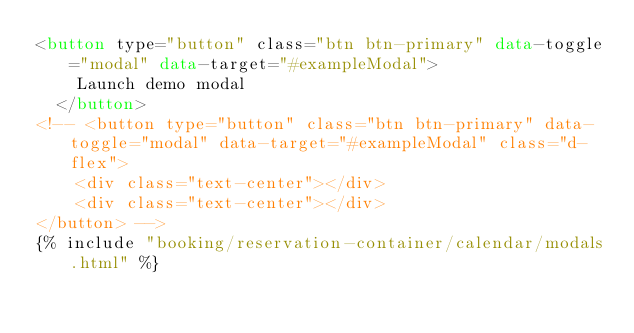<code> <loc_0><loc_0><loc_500><loc_500><_HTML_><button type="button" class="btn btn-primary" data-toggle="modal" data-target="#exampleModal">
    Launch demo modal
  </button>
<!-- <button type="button" class="btn btn-primary" data-toggle="modal" data-target="#exampleModal" class="d-flex">
    <div class="text-center"></div>
    <div class="text-center"></div>
</button> -->
{% include "booking/reservation-container/calendar/modals.html" %}</code> 